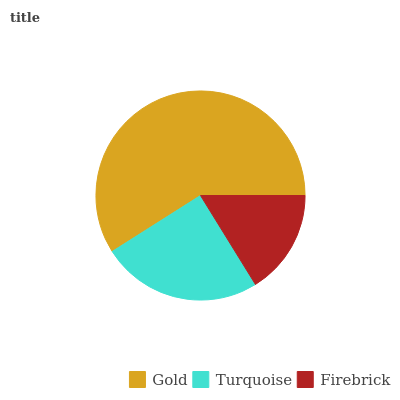Is Firebrick the minimum?
Answer yes or no. Yes. Is Gold the maximum?
Answer yes or no. Yes. Is Turquoise the minimum?
Answer yes or no. No. Is Turquoise the maximum?
Answer yes or no. No. Is Gold greater than Turquoise?
Answer yes or no. Yes. Is Turquoise less than Gold?
Answer yes or no. Yes. Is Turquoise greater than Gold?
Answer yes or no. No. Is Gold less than Turquoise?
Answer yes or no. No. Is Turquoise the high median?
Answer yes or no. Yes. Is Turquoise the low median?
Answer yes or no. Yes. Is Gold the high median?
Answer yes or no. No. Is Gold the low median?
Answer yes or no. No. 